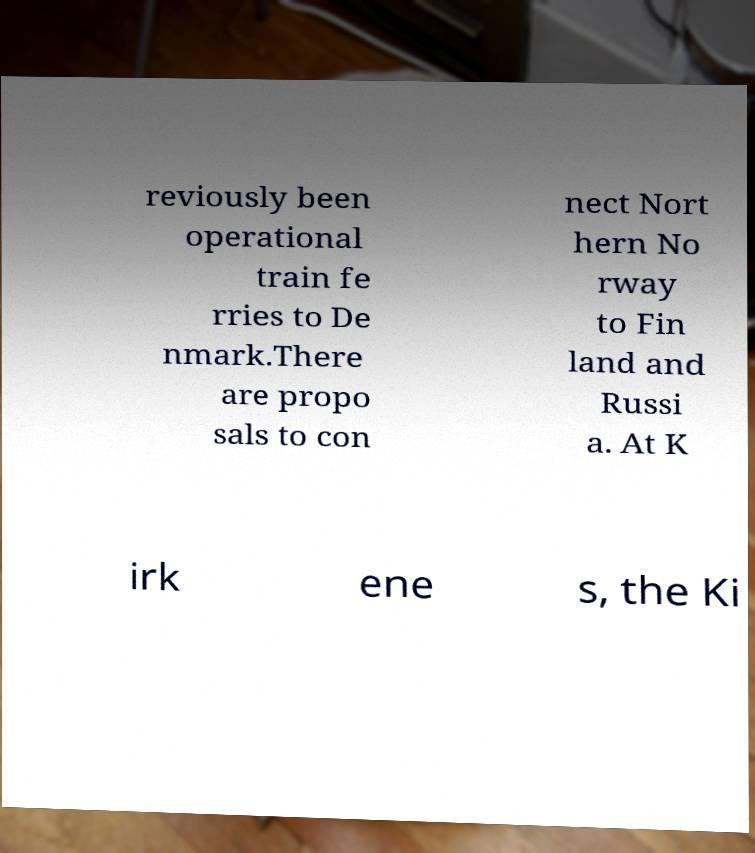Please identify and transcribe the text found in this image. reviously been operational train fe rries to De nmark.There are propo sals to con nect Nort hern No rway to Fin land and Russi a. At K irk ene s, the Ki 